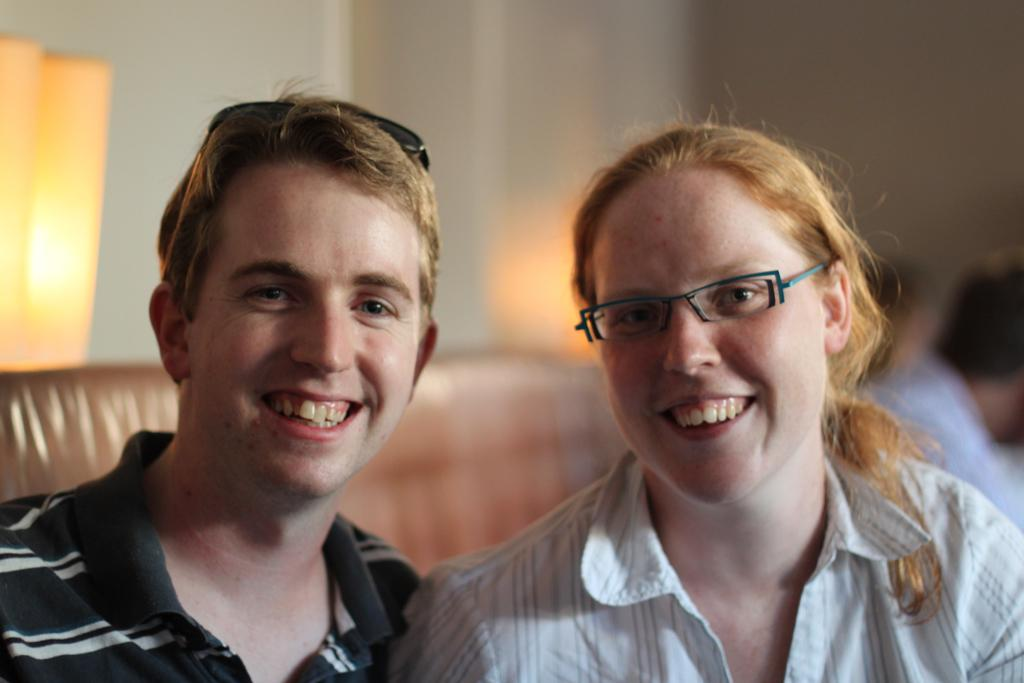What types of people are in the image? There are men and a woman in the image. What expressions do the people in the image have? The people in the image are smiling. What can be seen in the background of the image? There is a wall in the background of the image. What type of disgust can be seen on the children's faces in the image? There are no children present in the image, and therefore no such expressions can be observed. 